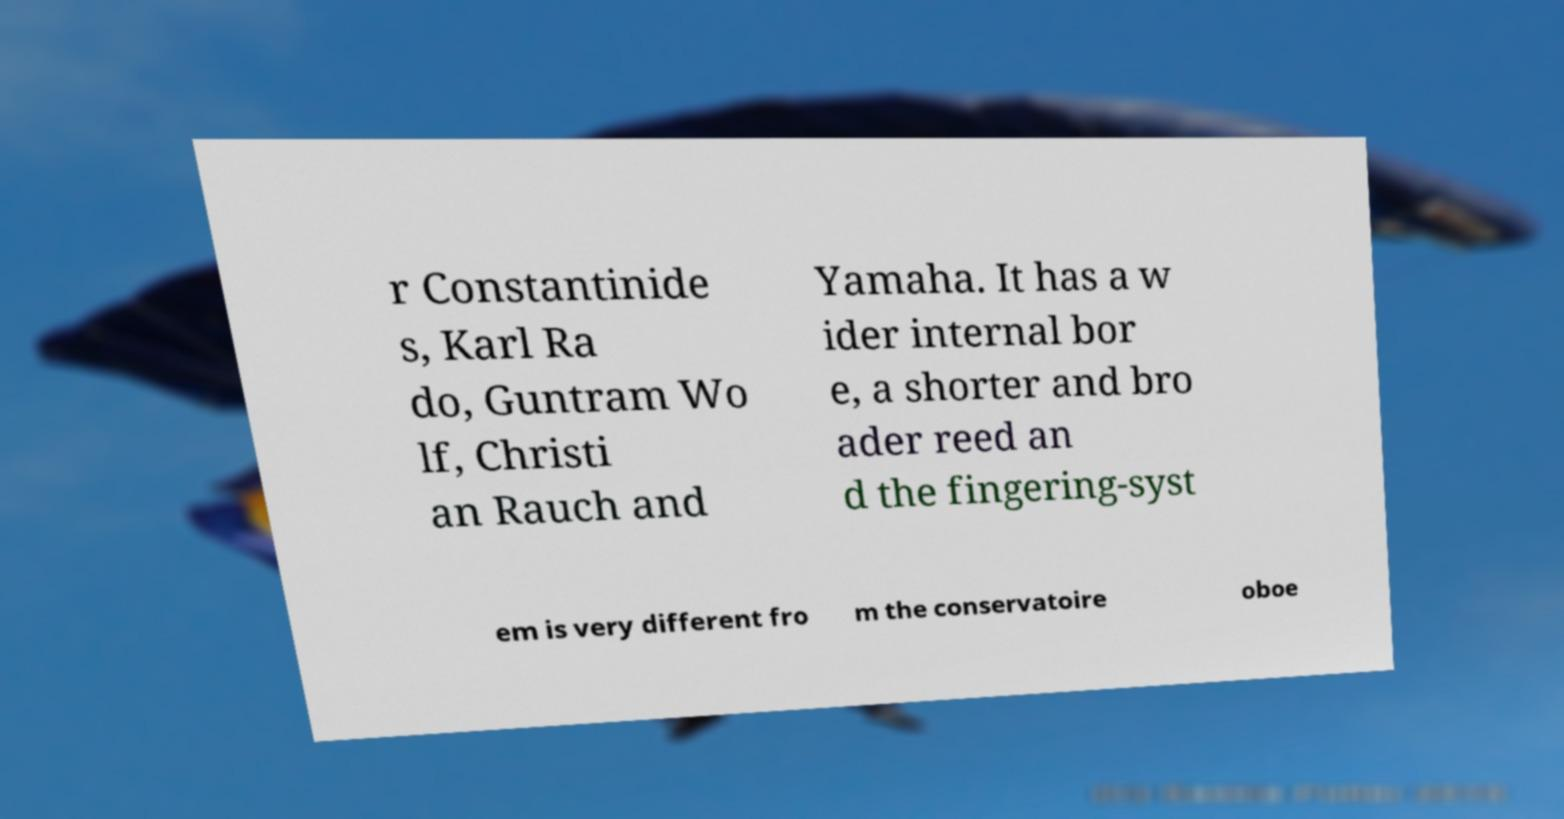Could you extract and type out the text from this image? r Constantinide s, Karl Ra do, Guntram Wo lf, Christi an Rauch and Yamaha. It has a w ider internal bor e, a shorter and bro ader reed an d the fingering-syst em is very different fro m the conservatoire oboe 